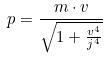<formula> <loc_0><loc_0><loc_500><loc_500>p = \frac { m \cdot v } { \sqrt { 1 + \frac { v ^ { 4 } } { j ^ { 4 } } } }</formula> 